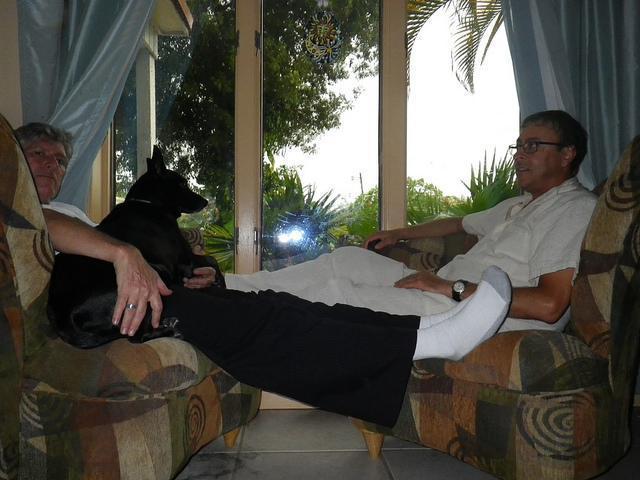How many couches are there?
Give a very brief answer. 2. How many people can you see?
Give a very brief answer. 2. How many cars have a surfboard on the roof?
Give a very brief answer. 0. 